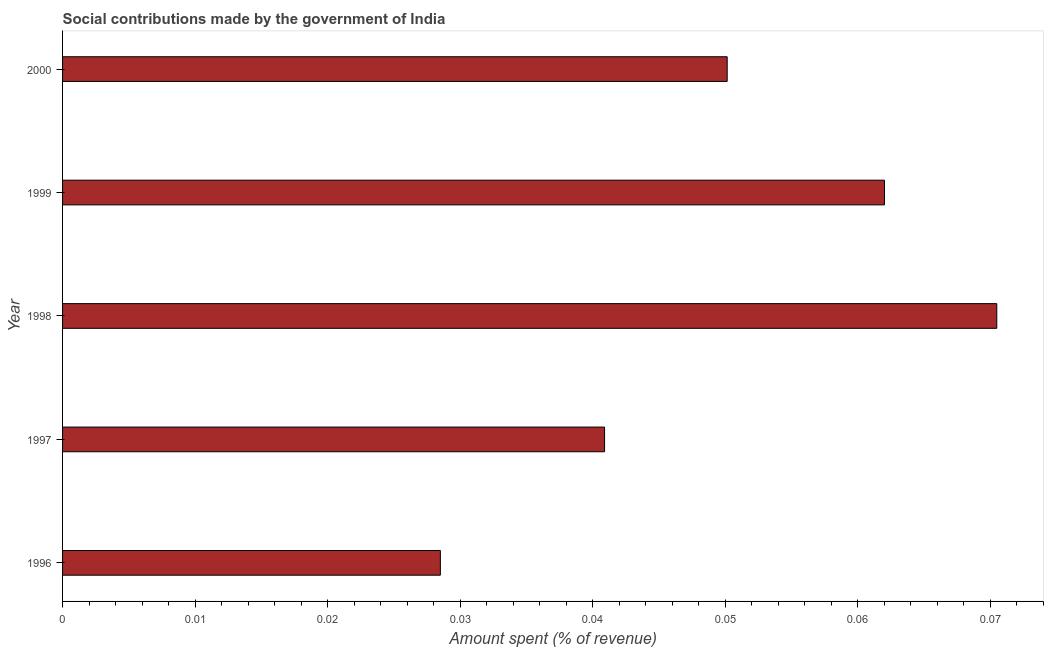What is the title of the graph?
Provide a short and direct response. Social contributions made by the government of India. What is the label or title of the X-axis?
Your response must be concise. Amount spent (% of revenue). What is the label or title of the Y-axis?
Your answer should be very brief. Year. What is the amount spent in making social contributions in 1999?
Your answer should be very brief. 0.06. Across all years, what is the maximum amount spent in making social contributions?
Your answer should be compact. 0.07. Across all years, what is the minimum amount spent in making social contributions?
Keep it short and to the point. 0.03. What is the sum of the amount spent in making social contributions?
Provide a short and direct response. 0.25. What is the average amount spent in making social contributions per year?
Your answer should be compact. 0.05. What is the median amount spent in making social contributions?
Give a very brief answer. 0.05. What is the ratio of the amount spent in making social contributions in 1997 to that in 1999?
Your response must be concise. 0.66. Is the amount spent in making social contributions in 1996 less than that in 1997?
Your answer should be compact. Yes. Is the difference between the amount spent in making social contributions in 1999 and 2000 greater than the difference between any two years?
Offer a very short reply. No. What is the difference between the highest and the second highest amount spent in making social contributions?
Keep it short and to the point. 0.01. Is the sum of the amount spent in making social contributions in 1996 and 1999 greater than the maximum amount spent in making social contributions across all years?
Make the answer very short. Yes. How many years are there in the graph?
Offer a terse response. 5. What is the difference between two consecutive major ticks on the X-axis?
Your response must be concise. 0.01. Are the values on the major ticks of X-axis written in scientific E-notation?
Offer a very short reply. No. What is the Amount spent (% of revenue) of 1996?
Your answer should be compact. 0.03. What is the Amount spent (% of revenue) in 1997?
Offer a very short reply. 0.04. What is the Amount spent (% of revenue) in 1998?
Keep it short and to the point. 0.07. What is the Amount spent (% of revenue) in 1999?
Your answer should be very brief. 0.06. What is the Amount spent (% of revenue) of 2000?
Offer a terse response. 0.05. What is the difference between the Amount spent (% of revenue) in 1996 and 1997?
Your answer should be very brief. -0.01. What is the difference between the Amount spent (% of revenue) in 1996 and 1998?
Your answer should be compact. -0.04. What is the difference between the Amount spent (% of revenue) in 1996 and 1999?
Provide a succinct answer. -0.03. What is the difference between the Amount spent (% of revenue) in 1996 and 2000?
Your answer should be compact. -0.02. What is the difference between the Amount spent (% of revenue) in 1997 and 1998?
Give a very brief answer. -0.03. What is the difference between the Amount spent (% of revenue) in 1997 and 1999?
Give a very brief answer. -0.02. What is the difference between the Amount spent (% of revenue) in 1997 and 2000?
Your response must be concise. -0.01. What is the difference between the Amount spent (% of revenue) in 1998 and 1999?
Provide a short and direct response. 0.01. What is the difference between the Amount spent (% of revenue) in 1998 and 2000?
Offer a terse response. 0.02. What is the difference between the Amount spent (% of revenue) in 1999 and 2000?
Offer a very short reply. 0.01. What is the ratio of the Amount spent (% of revenue) in 1996 to that in 1997?
Your response must be concise. 0.7. What is the ratio of the Amount spent (% of revenue) in 1996 to that in 1998?
Give a very brief answer. 0.4. What is the ratio of the Amount spent (% of revenue) in 1996 to that in 1999?
Your response must be concise. 0.46. What is the ratio of the Amount spent (% of revenue) in 1996 to that in 2000?
Keep it short and to the point. 0.57. What is the ratio of the Amount spent (% of revenue) in 1997 to that in 1998?
Your answer should be compact. 0.58. What is the ratio of the Amount spent (% of revenue) in 1997 to that in 1999?
Your response must be concise. 0.66. What is the ratio of the Amount spent (% of revenue) in 1997 to that in 2000?
Provide a succinct answer. 0.81. What is the ratio of the Amount spent (% of revenue) in 1998 to that in 1999?
Ensure brevity in your answer.  1.14. What is the ratio of the Amount spent (% of revenue) in 1998 to that in 2000?
Your answer should be compact. 1.41. What is the ratio of the Amount spent (% of revenue) in 1999 to that in 2000?
Provide a succinct answer. 1.24. 